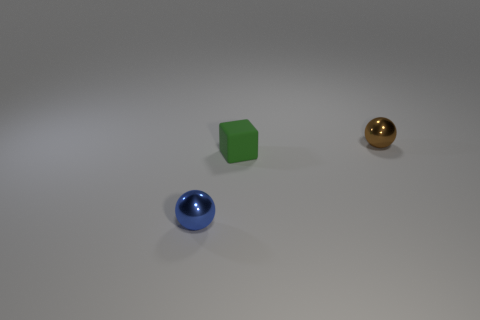Add 2 small red shiny cylinders. How many objects exist? 5 Subtract all spheres. How many objects are left? 1 Subtract all blue blocks. How many green balls are left? 0 Add 1 cyan rubber things. How many cyan rubber things exist? 1 Subtract all blue balls. How many balls are left? 1 Subtract 0 blue cylinders. How many objects are left? 3 Subtract 1 blocks. How many blocks are left? 0 Subtract all gray blocks. Subtract all cyan cylinders. How many blocks are left? 1 Subtract all blue metal cubes. Subtract all small green cubes. How many objects are left? 2 Add 3 small blue things. How many small blue things are left? 4 